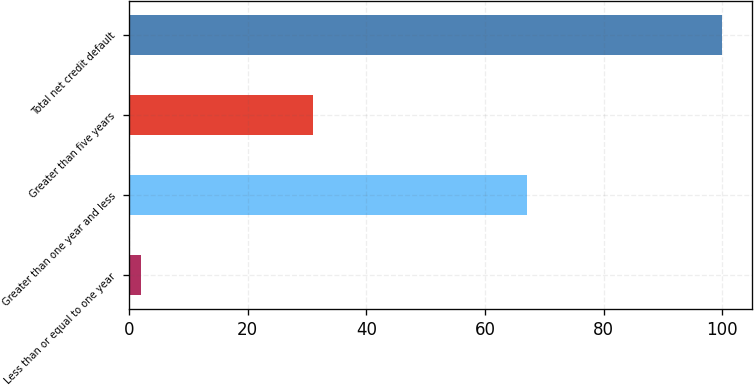Convert chart to OTSL. <chart><loc_0><loc_0><loc_500><loc_500><bar_chart><fcel>Less than or equal to one year<fcel>Greater than one year and less<fcel>Greater than five years<fcel>Total net credit default<nl><fcel>2<fcel>67<fcel>31<fcel>100<nl></chart> 